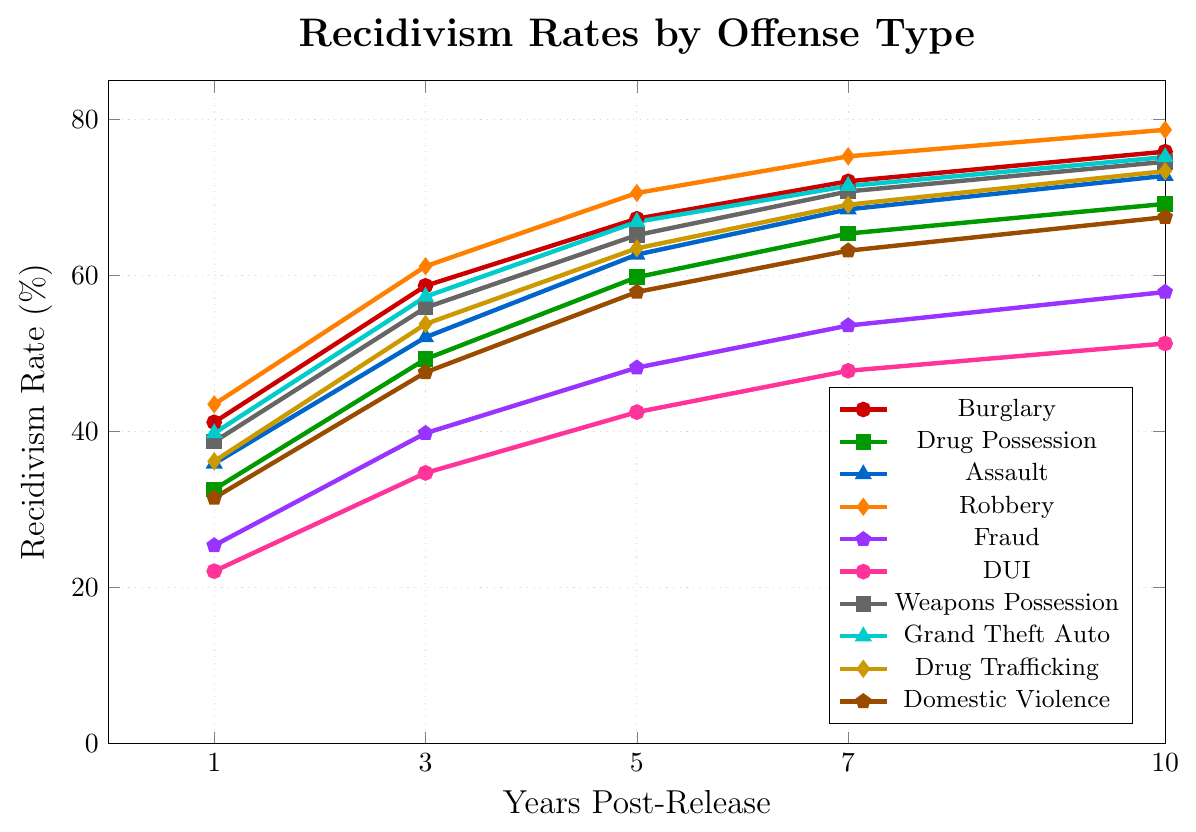What's the recidivism rate for Drug Possession at 5 years post-release? Identify the Drug Possession line (green with square markers), then find the 5-year mark on the x-axis and read the corresponding y-value. The recidivism rate is 59.8%.
Answer: 59.8% Which type of offense has the highest recidivism rate at 10 years post-release? Observe all 10-year endpoint markers and identify the highest value. Robbery (orange with diamond markers) has the highest recidivism rate at 10 years with 78.7%.
Answer: Robbery What is the difference in recidivism rates between Burglary and DUI at 3 years post-release? Find the 3-year recidivism rates for Burglary (red with circle markers) and DUI (pink with circle markers), then subtract the latter from the former: 58.7% - 34.7% = 24%.
Answer: 24% What is the average recidivism rate for Assault over the 10-year period? Calculate the average of the recidivism rates for Assault (blue with triangle markers): (35.9 + 52.1 + 62.7 + 68.5 + 72.8) / 5 = 58.4%.
Answer: 58.4% How do the recidivism rates for Domestic Violence and Drug Trafficking compare at 7 years post-release? Compare the values at 7 years for Domestic Violence (brown with pentagon markers) and Drug Trafficking (yellow with diamond markers): 63.2% (Domestic Violence) vs. 69.1% (Drug Trafficking). Drug Trafficking has a higher rate by 5.9%.
Answer: Drug Trafficking by 5.9% Which offense type shows the smallest increase in recidivism rate from 1 year to 10 years post-release? Calculate the increase for each offense type from 1 year to 10 years and find the smallest: DUI (pink with circle markers) increases by 51.3% - 22.1% = 29.2%.
Answer: DUI What trend is observed in recidivism rates for Grand Theft Auto over the 10-year period? Observe the line for Grand Theft Auto (teal with triangle markers). The recidivism rate increases gradually from 39.8% at 1 year to 75.2% at 10 years.
Answer: Increasing trend Which offense type’s recidivism rate is closest to 50% at 3 years post-release? Find the 3-year recidivism rates and identify the closest to 50%: Domestic Violence (brown with pentagon markers) is 47.6%, which is closest to 50%.
Answer: Domestic Violence What is the combined recidivism rate for Fraud and Drug Possession at 7 years post-release? Add the recidivism rates for Fraud (purple with pentagon markers) and Drug Possession (green with square markers) at 7 years: 53.6% + 65.4% = 119%.
Answer: 119% Comparing Burglary and Grand Theft Auto, which shows a higher rate at 5 years post-release? Compare the 5-year rates for Burglary (red with circle markers) and Grand Theft Auto (teal with triangle markers): 67.3% (Burglary) vs. 66.9% (Grand Theft Auto). Burglary is higher by 0.4%.
Answer: Burglary by 0.4% 